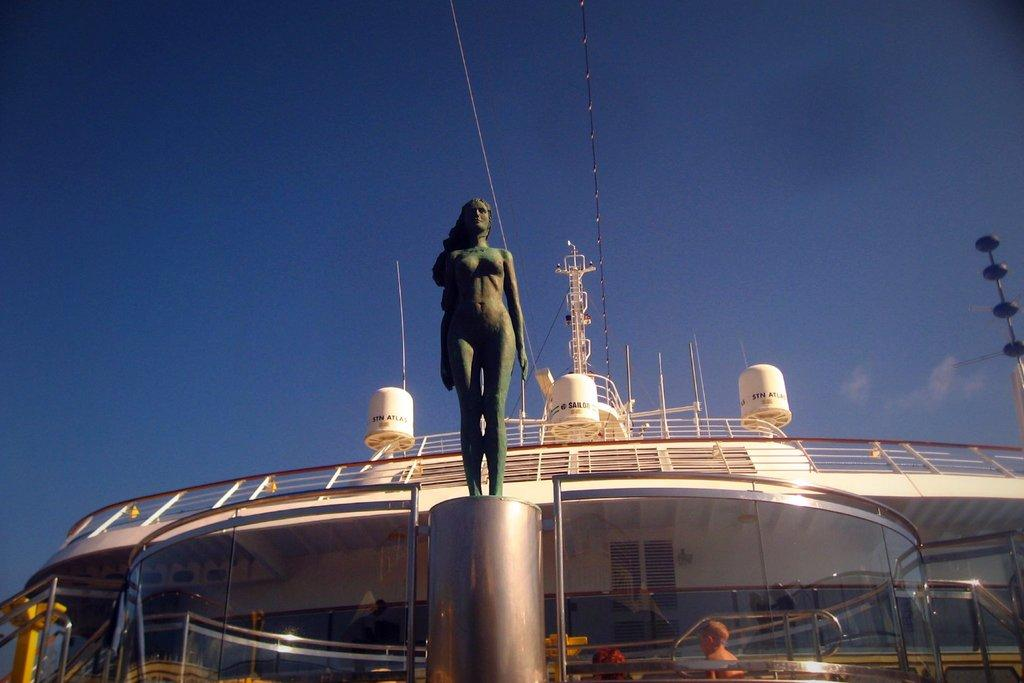What is the main subject in the image? There is a statue in the image. What type of structure is visible in the image? There is a glass wall in the image. What is the secondary subject in the image? There is a ship in the image. What else can be seen in the image? There are wires in the image. What is the color of the sky in the background? The sky is blue in the background. What else can be seen in the sky in the background? There are clouds in the sky in the background. How many dogs are sitting next to the statue in the image? There are no dogs present in the image. What does the mom say about the statue in the image? There is no mention of a mom or any dialogue in the image. 